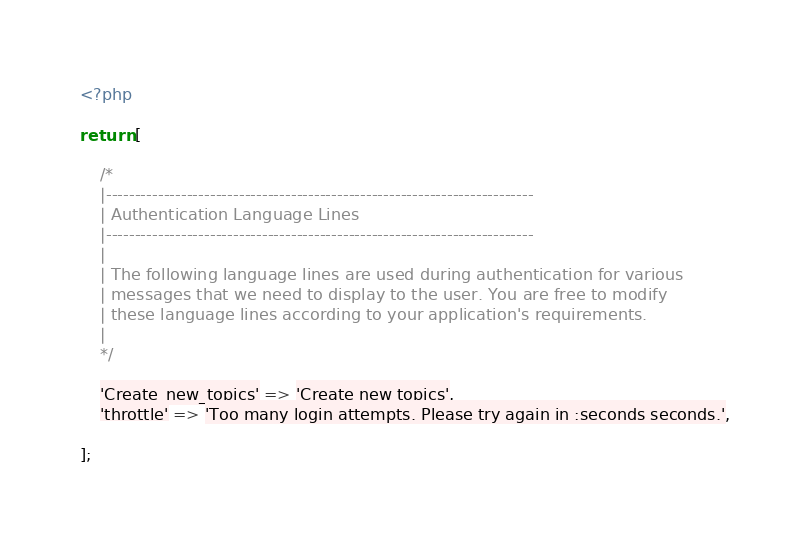<code> <loc_0><loc_0><loc_500><loc_500><_PHP_><?php

return [

    /*
    |--------------------------------------------------------------------------
    | Authentication Language Lines
    |--------------------------------------------------------------------------
    |
    | The following language lines are used during authentication for various
    | messages that we need to display to the user. You are free to modify
    | these language lines according to your application's requirements.
    |
    */

    'Create_new_topics' => 'Create new topics',
    'throttle' => 'Too many login attempts. Please try again in :seconds seconds.',

];
</code> 